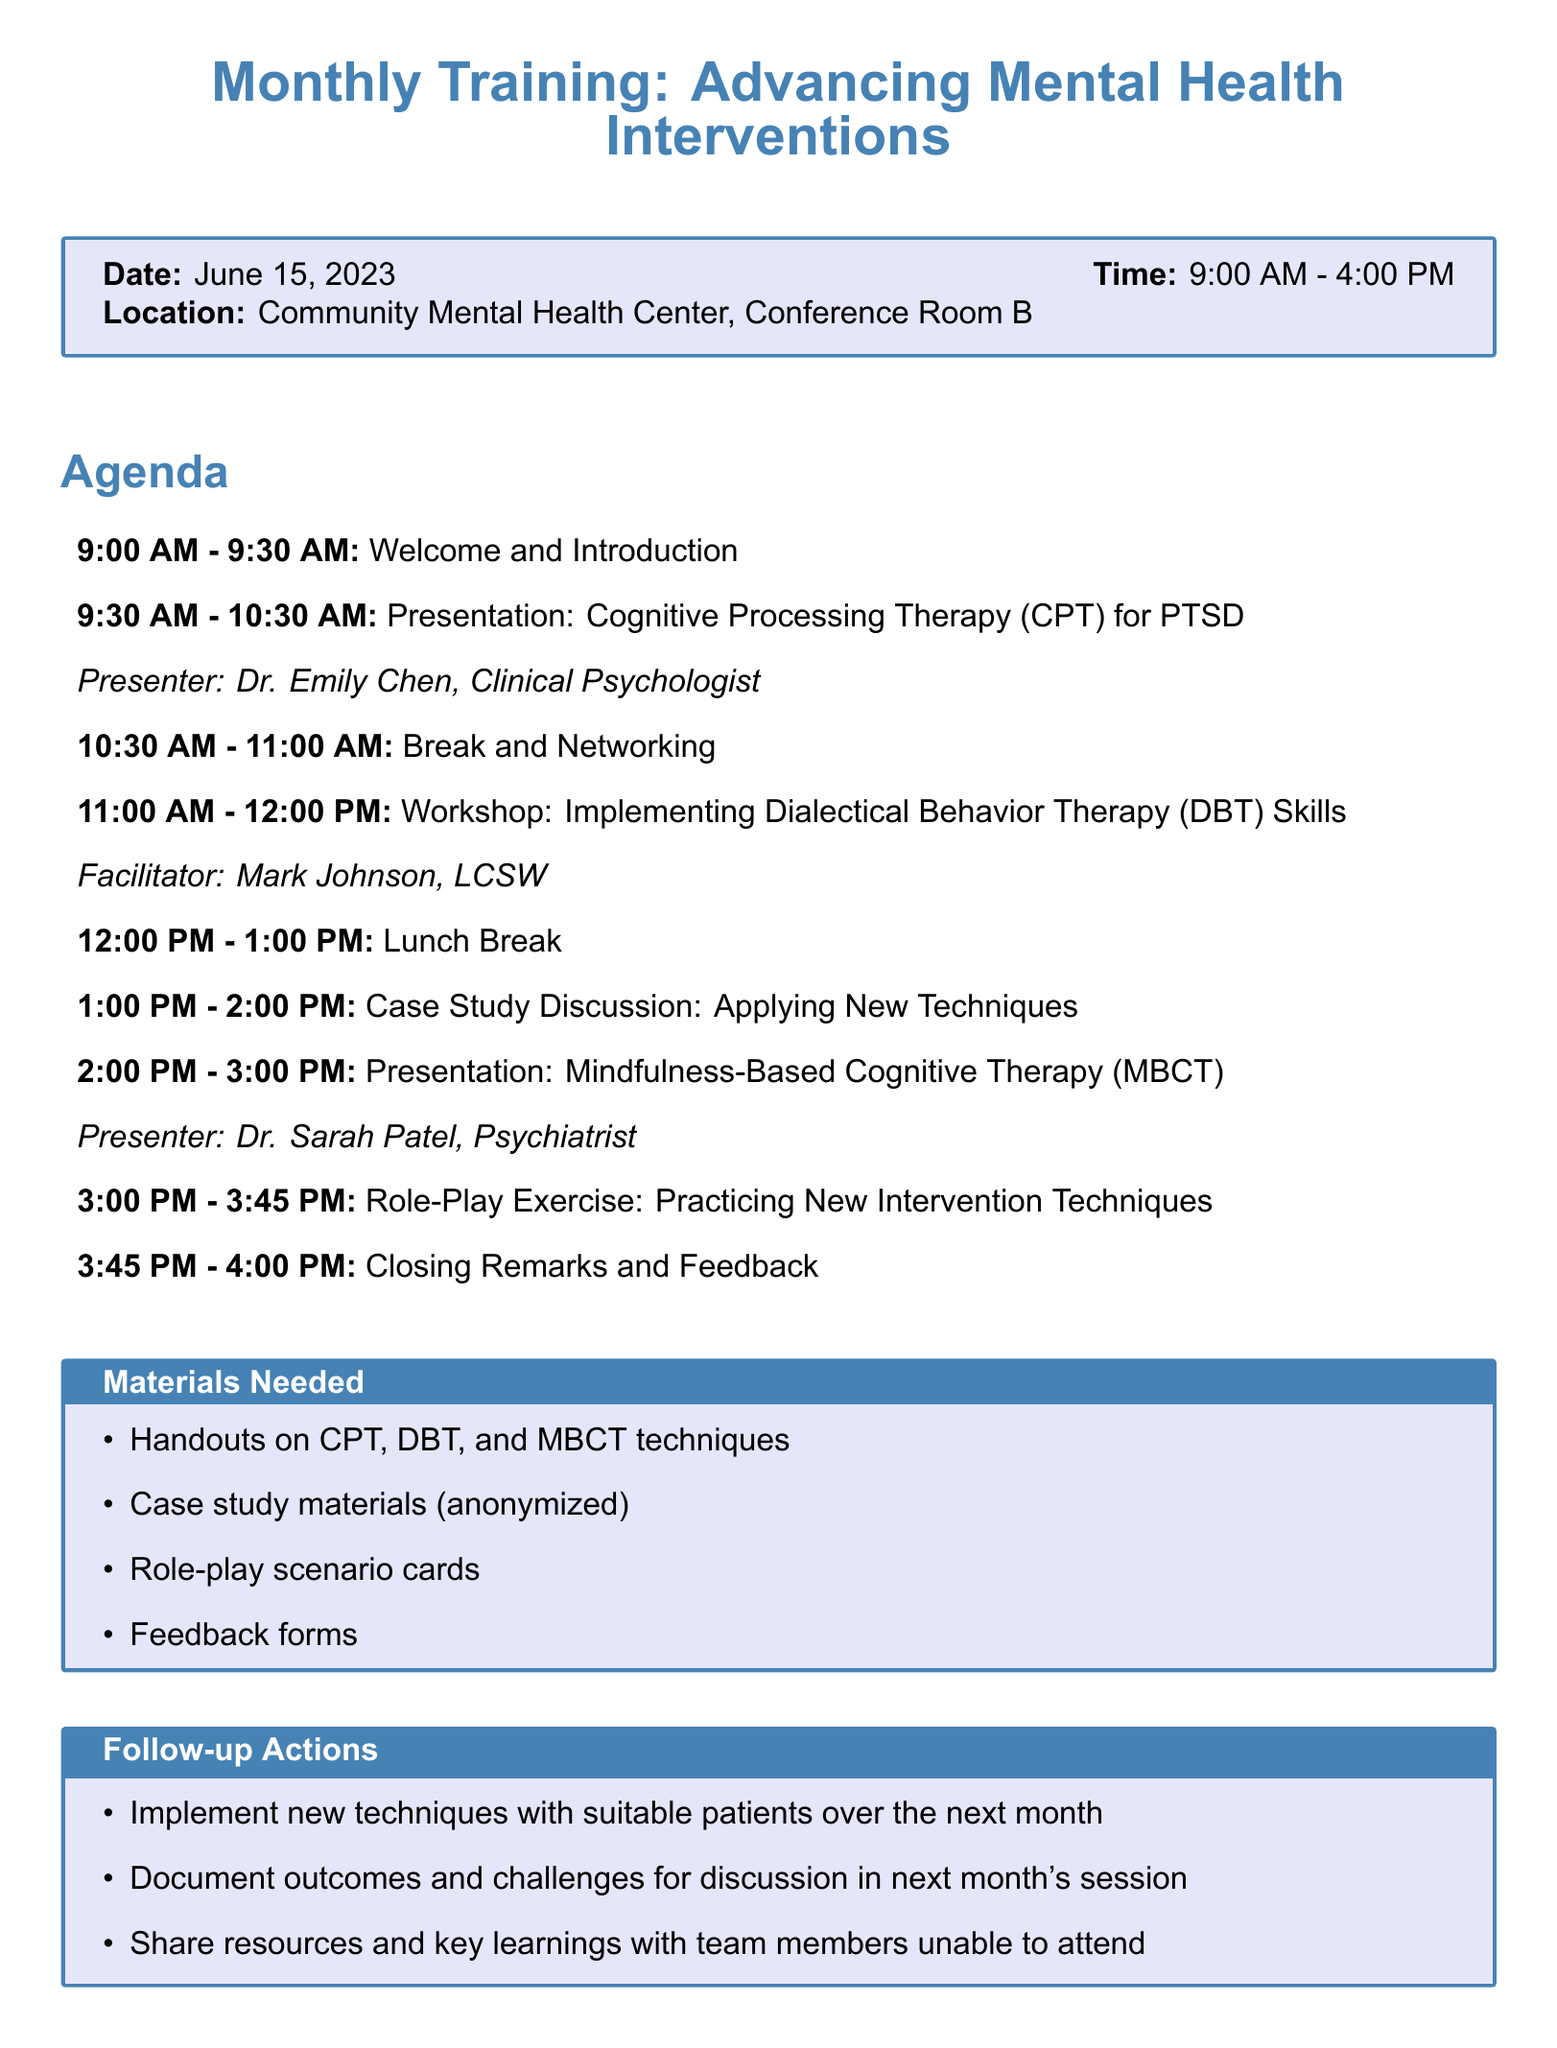What is the session title? The session title is explicitly stated at the beginning of the document.
Answer: Monthly Training: Advancing Mental Health Interventions What is the date of the training session? The date is indicated clearly within the session details.
Answer: June 15, 2023 Who is presenting on Cognitive Processing Therapy? The presenter's name is associated with the specific activity in the agenda.
Answer: Dr. Emily Chen, Clinical Psychologist What time is the Role-Play Exercise scheduled? The agenda lists specific times for each activity, including the Role-Play Exercise.
Answer: 3:00 PM - 3:45 PM What is one required material for the session? The materials needed are included in a separate section, listing all necessary materials for the training.
Answer: Handouts on CPT, DBT, and MBCT techniques What activity comes after the lunch break? The order of activities is sequentially listed in the agenda.
Answer: Case Study Discussion: Applying New Techniques What action should participants take after the training session? Follow-up actions are outlined clearly towards the end of the document.
Answer: Implement new techniques with suitable patients over the next month What is the purpose of the Case Study Discussion? The purpose of this activity is described in the agenda item itself, indicating its focus.
Answer: Group analysis of how new interventions could benefit specific patients from our caseload, respecting confidentiality 